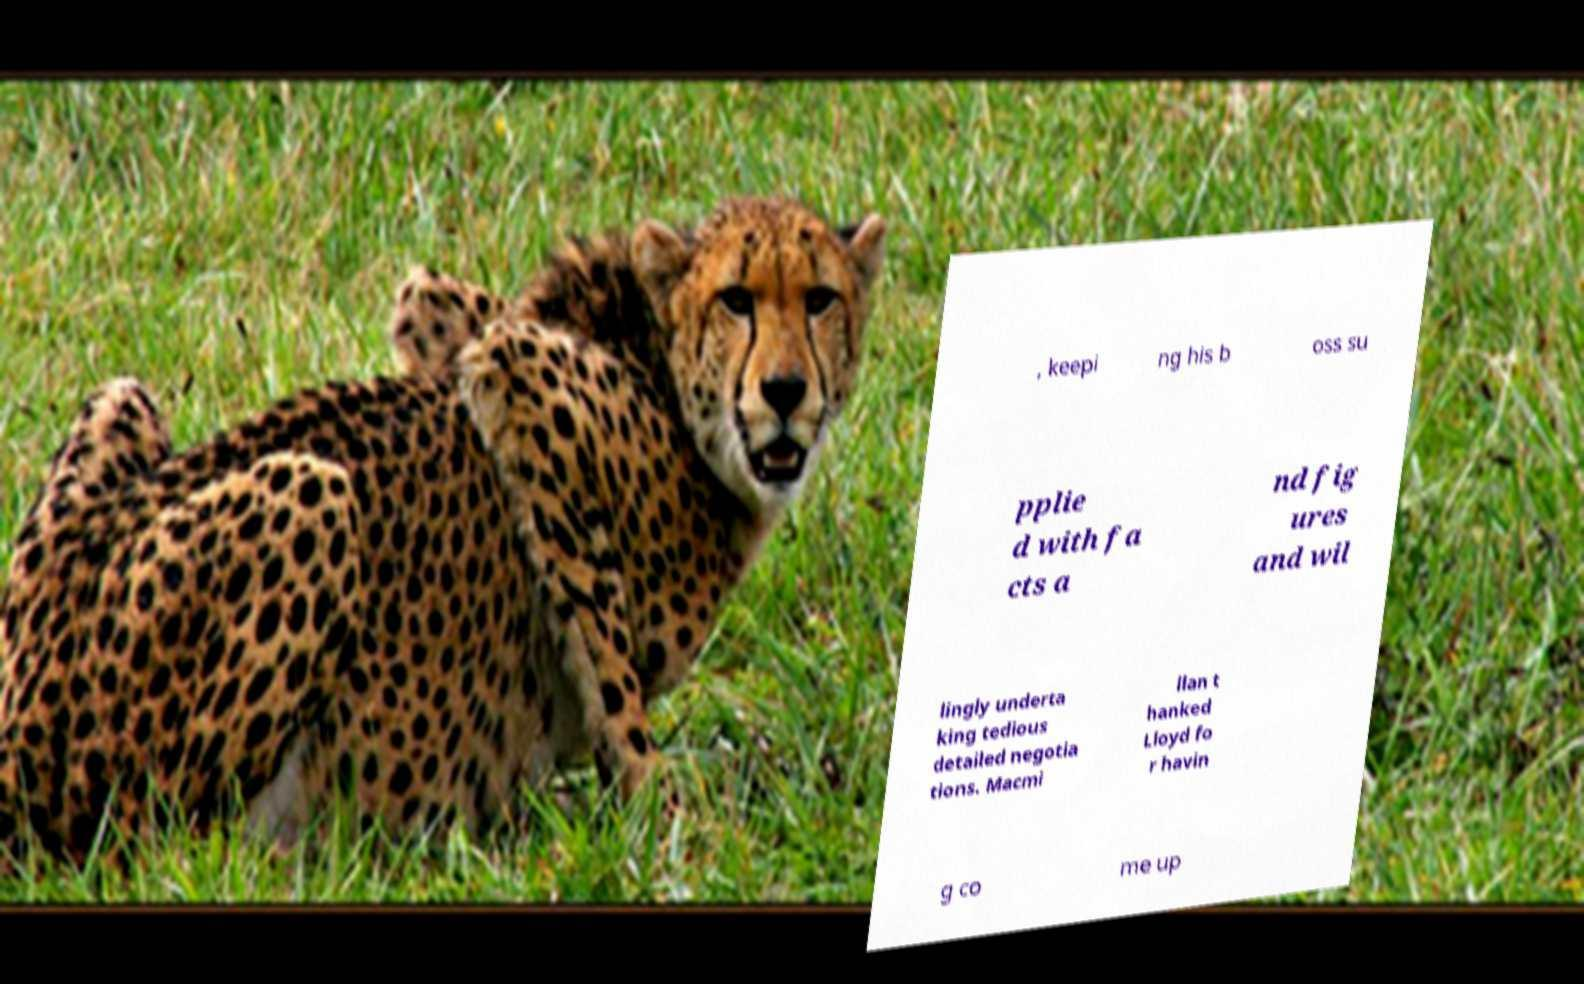Please read and relay the text visible in this image. What does it say? , keepi ng his b oss su pplie d with fa cts a nd fig ures and wil lingly underta king tedious detailed negotia tions. Macmi llan t hanked Lloyd fo r havin g co me up 